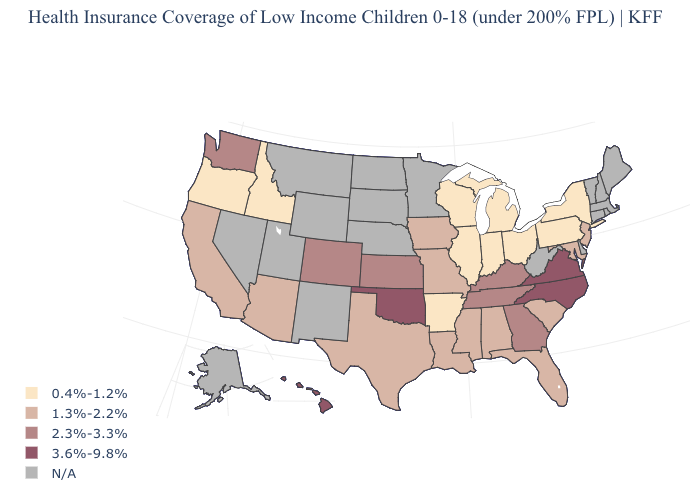Does the map have missing data?
Short answer required. Yes. What is the value of Arkansas?
Keep it brief. 0.4%-1.2%. Which states hav the highest value in the MidWest?
Write a very short answer. Kansas. Which states have the lowest value in the MidWest?
Write a very short answer. Illinois, Indiana, Michigan, Ohio, Wisconsin. Which states hav the highest value in the MidWest?
Write a very short answer. Kansas. Among the states that border Oregon , which have the lowest value?
Give a very brief answer. Idaho. What is the value of Missouri?
Write a very short answer. 1.3%-2.2%. Among the states that border New Mexico , does Colorado have the highest value?
Be succinct. No. Does the first symbol in the legend represent the smallest category?
Concise answer only. Yes. Does the map have missing data?
Give a very brief answer. Yes. Which states have the lowest value in the South?
Keep it brief. Arkansas. How many symbols are there in the legend?
Give a very brief answer. 5. What is the highest value in the South ?
Give a very brief answer. 3.6%-9.8%. 